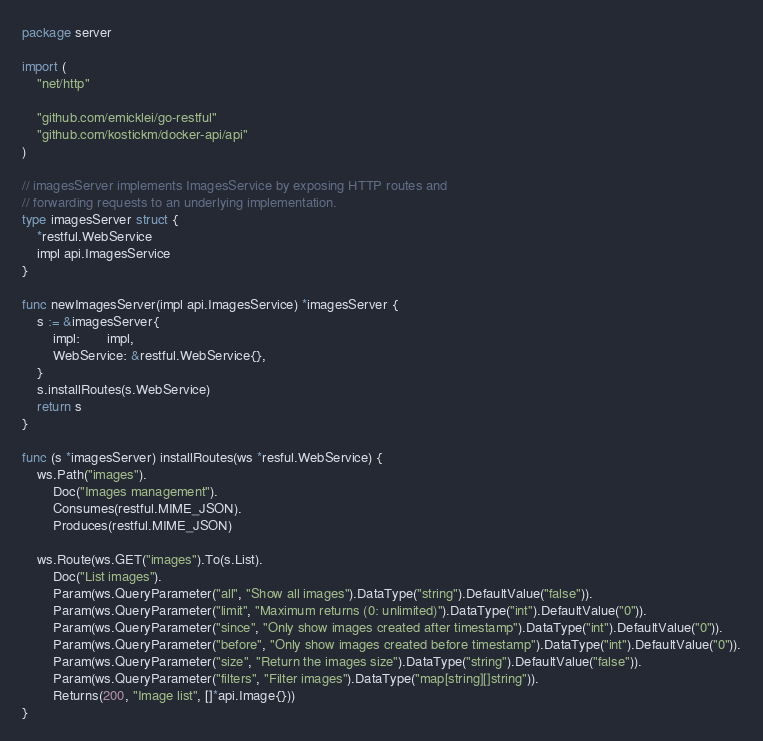<code> <loc_0><loc_0><loc_500><loc_500><_Go_>package server

import (
	"net/http"

	"github.com/emicklei/go-restful"
	"github.com/kostickm/docker-api/api"
)

// imagesServer implements ImagesService by exposing HTTP routes and
// forwarding requests to an underlying implementation.
type imagesServer struct {
	*restful.WebService
	impl api.ImagesService
}

func newImagesServer(impl api.ImagesService) *imagesServer {
	s := &imagesServer{
		impl:       impl,
		WebService: &restful.WebService{},
	}
	s.installRoutes(s.WebService)
	return s
}

func (s *imagesServer) installRoutes(ws *resful.WebService) {
	ws.Path("images").
		Doc("Images management").
		Consumes(restful.MIME_JSON).
		Produces(restful.MIME_JSON)

	ws.Route(ws.GET("images").To(s.List).
		Doc("List images").
		Param(ws.QueryParameter("all", "Show all images").DataType("string").DefaultValue("false")).
		Param(ws.QueryParameter("limit", "Maximum returns (0: unlimited)").DataType("int").DefaultValue("0")).
		Param(ws.QueryParameter("since", "Only show images created after timestamp").DataType("int").DefaultValue("0")).
		Param(ws.QueryParameter("before", "Only show images created before timestamp").DataType("int").DefaultValue("0")).
		Param(ws.QueryParameter("size", "Return the images size").DataType("string").DefaultValue("false")).
		Param(ws.QueryParameter("filters", "Filter images").DataType("map[string][]string")).
		Returns(200, "Image list", []*api.Image{}))
}
</code> 